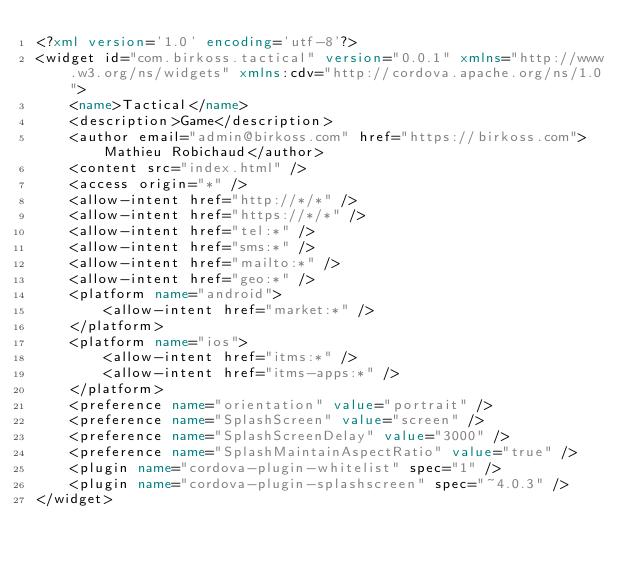Convert code to text. <code><loc_0><loc_0><loc_500><loc_500><_XML_><?xml version='1.0' encoding='utf-8'?>
<widget id="com.birkoss.tactical" version="0.0.1" xmlns="http://www.w3.org/ns/widgets" xmlns:cdv="http://cordova.apache.org/ns/1.0">
    <name>Tactical</name>
    <description>Game</description>
    <author email="admin@birkoss.com" href="https://birkoss.com">Mathieu Robichaud</author>
    <content src="index.html" />
    <access origin="*" />
    <allow-intent href="http://*/*" />
    <allow-intent href="https://*/*" />
    <allow-intent href="tel:*" />
    <allow-intent href="sms:*" />
    <allow-intent href="mailto:*" />
    <allow-intent href="geo:*" />
    <platform name="android">
        <allow-intent href="market:*" />
    </platform>
    <platform name="ios">
        <allow-intent href="itms:*" />
        <allow-intent href="itms-apps:*" />
    </platform>
    <preference name="orientation" value="portrait" />
    <preference name="SplashScreen" value="screen" />
    <preference name="SplashScreenDelay" value="3000" />
    <preference name="SplashMaintainAspectRatio" value="true" />
    <plugin name="cordova-plugin-whitelist" spec="1" />
    <plugin name="cordova-plugin-splashscreen" spec="~4.0.3" />
</widget>
</code> 